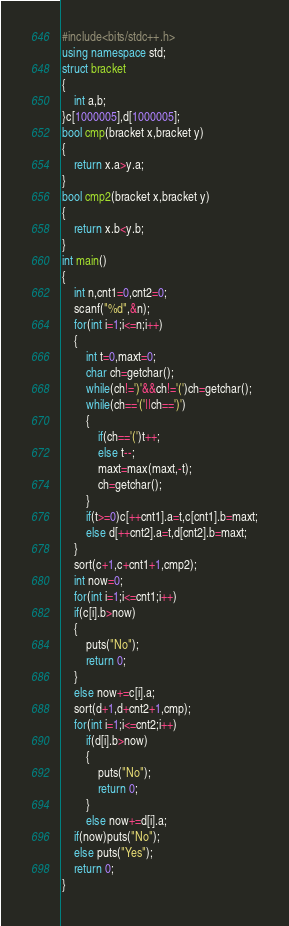<code> <loc_0><loc_0><loc_500><loc_500><_C++_>#include<bits/stdc++.h>
using namespace std;
struct bracket
{
	int a,b;
}c[1000005],d[1000005];
bool cmp(bracket x,bracket y)
{
	return x.a>y.a;
}
bool cmp2(bracket x,bracket y)
{
	return x.b<y.b;
}
int main()
{
	int n,cnt1=0,cnt2=0;
	scanf("%d",&n);
	for(int i=1;i<=n;i++)
	{
		int t=0,maxt=0;
		char ch=getchar();
		while(ch!=')'&&ch!='(')ch=getchar();
		while(ch=='('||ch==')')
		{
			if(ch=='(')t++;
			else t--;
			maxt=max(maxt,-t);
			ch=getchar();
		}
		if(t>=0)c[++cnt1].a=t,c[cnt1].b=maxt;
		else d[++cnt2].a=t,d[cnt2].b=maxt;
	}
	sort(c+1,c+cnt1+1,cmp2);
	int now=0;
	for(int i=1;i<=cnt1;i++)
	if(c[i].b>now)
	{
		puts("No");
		return 0;
	}
	else now+=c[i].a;
	sort(d+1,d+cnt2+1,cmp);
	for(int i=1;i<=cnt2;i++)
		if(d[i].b>now)
		{
			puts("No");
			return 0;
		}
		else now+=d[i].a;
	if(now)puts("No");
	else puts("Yes");
	return 0;
}</code> 